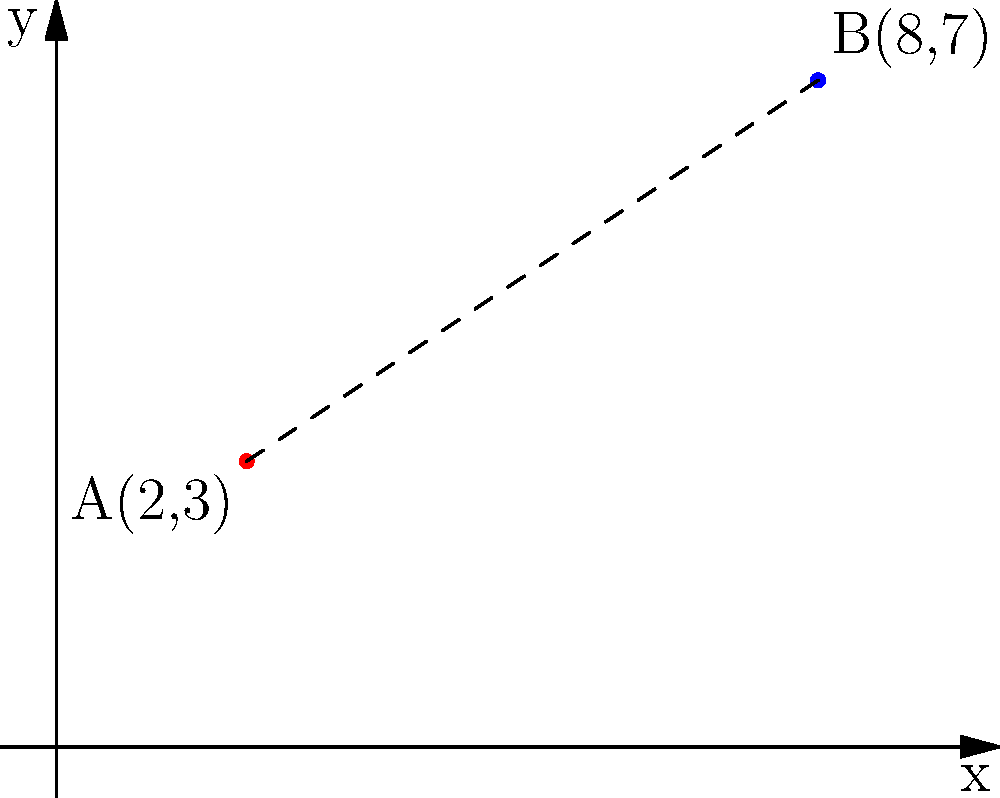As a software engineer developing data analytics tools for marketing campaigns, you need to calculate the distance between two campaign locations on a coordinate plane. Location A is at point (2, 3) and location B is at point (8, 7). What is the distance between these two locations? To calculate the distance between two points on a coordinate plane, we can use the distance formula, which is derived from the Pythagorean theorem:

$$ d = \sqrt{(x_2 - x_1)^2 + (y_2 - y_1)^2} $$

Where $(x_1, y_1)$ are the coordinates of the first point and $(x_2, y_2)$ are the coordinates of the second point.

Let's plug in our values:
* Point A: $(x_1, y_1) = (2, 3)$
* Point B: $(x_2, y_2) = (8, 7)$

Now, let's calculate:

1) $x_2 - x_1 = 8 - 2 = 6$
2) $y_2 - y_1 = 7 - 3 = 4$

3) $(x_2 - x_1)^2 = 6^2 = 36$
4) $(y_2 - y_1)^2 = 4^2 = 16$

5) $(x_2 - x_1)^2 + (y_2 - y_1)^2 = 36 + 16 = 52$

6) $d = \sqrt{52}$

7) Simplify: $d = 2\sqrt{13}$

Therefore, the distance between the two marketing campaign locations is $2\sqrt{13}$ units.
Answer: $2\sqrt{13}$ units 